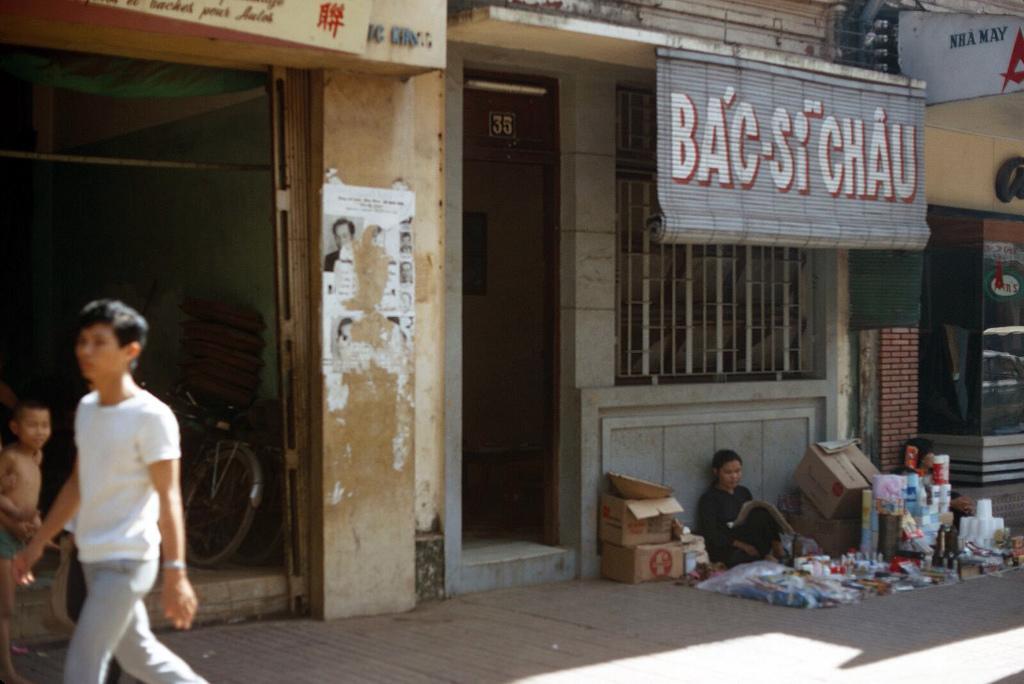Could you give a brief overview of what you see in this image? In this image I can see there is a building and there are boards attached to it. And in front of the building there is a sidewalk. And there are persons. And there is a glass. And there is a person sitting on the ground with some items like cups, Bottles, Cover, Boxes and few objects. And there is a bicycle. 